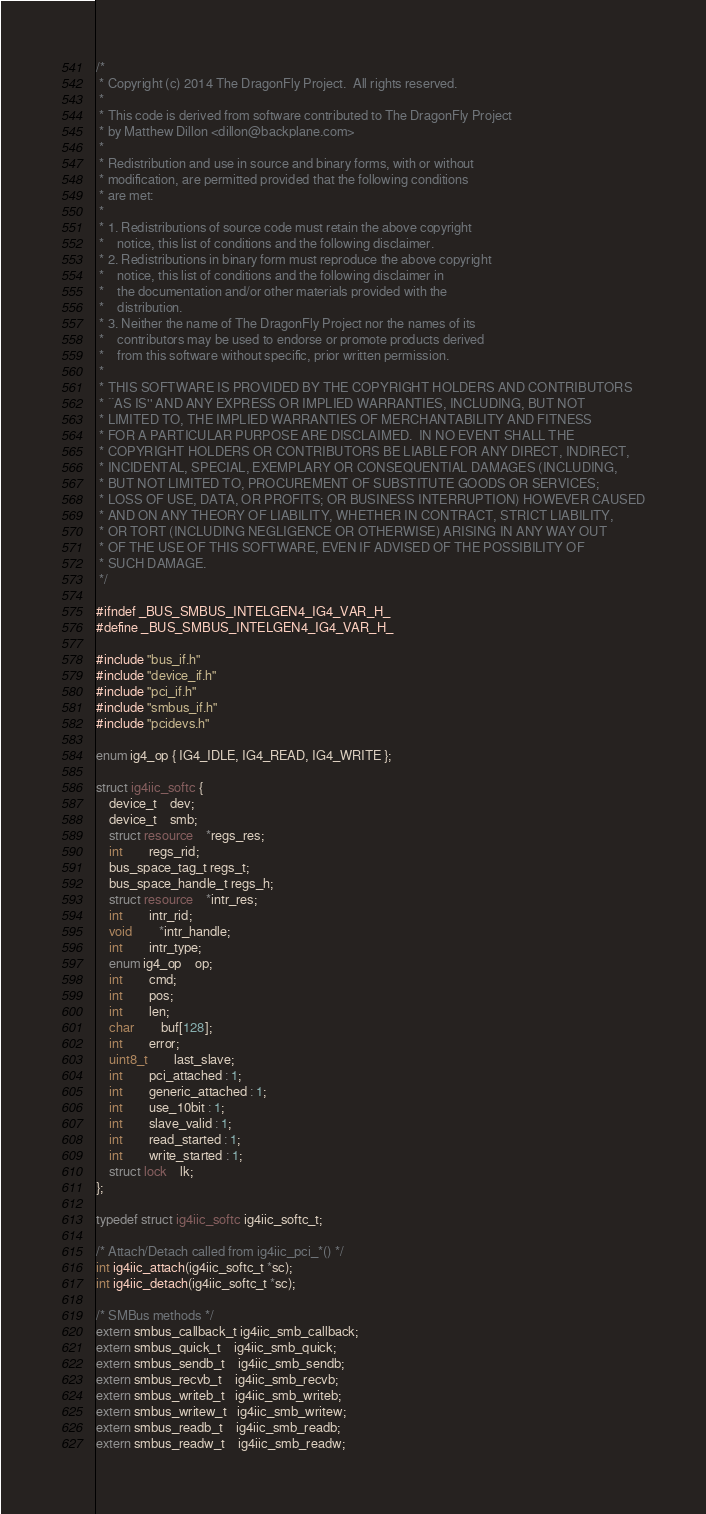<code> <loc_0><loc_0><loc_500><loc_500><_C_>/*
 * Copyright (c) 2014 The DragonFly Project.  All rights reserved.
 *
 * This code is derived from software contributed to The DragonFly Project
 * by Matthew Dillon <dillon@backplane.com>
 *
 * Redistribution and use in source and binary forms, with or without
 * modification, are permitted provided that the following conditions
 * are met:
 *
 * 1. Redistributions of source code must retain the above copyright
 *    notice, this list of conditions and the following disclaimer.
 * 2. Redistributions in binary form must reproduce the above copyright
 *    notice, this list of conditions and the following disclaimer in
 *    the documentation and/or other materials provided with the
 *    distribution.
 * 3. Neither the name of The DragonFly Project nor the names of its
 *    contributors may be used to endorse or promote products derived
 *    from this software without specific, prior written permission.
 *
 * THIS SOFTWARE IS PROVIDED BY THE COPYRIGHT HOLDERS AND CONTRIBUTORS
 * ``AS IS'' AND ANY EXPRESS OR IMPLIED WARRANTIES, INCLUDING, BUT NOT
 * LIMITED TO, THE IMPLIED WARRANTIES OF MERCHANTABILITY AND FITNESS
 * FOR A PARTICULAR PURPOSE ARE DISCLAIMED.  IN NO EVENT SHALL THE
 * COPYRIGHT HOLDERS OR CONTRIBUTORS BE LIABLE FOR ANY DIRECT, INDIRECT,
 * INCIDENTAL, SPECIAL, EXEMPLARY OR CONSEQUENTIAL DAMAGES (INCLUDING,
 * BUT NOT LIMITED TO, PROCUREMENT OF SUBSTITUTE GOODS OR SERVICES;
 * LOSS OF USE, DATA, OR PROFITS; OR BUSINESS INTERRUPTION) HOWEVER CAUSED
 * AND ON ANY THEORY OF LIABILITY, WHETHER IN CONTRACT, STRICT LIABILITY,
 * OR TORT (INCLUDING NEGLIGENCE OR OTHERWISE) ARISING IN ANY WAY OUT
 * OF THE USE OF THIS SOFTWARE, EVEN IF ADVISED OF THE POSSIBILITY OF
 * SUCH DAMAGE.
 */

#ifndef _BUS_SMBUS_INTELGEN4_IG4_VAR_H_
#define _BUS_SMBUS_INTELGEN4_IG4_VAR_H_

#include "bus_if.h"
#include "device_if.h"
#include "pci_if.h"
#include "smbus_if.h"
#include "pcidevs.h"

enum ig4_op { IG4_IDLE, IG4_READ, IG4_WRITE };

struct ig4iic_softc {
	device_t	dev;
	device_t	smb;
	struct resource	*regs_res;
	int		regs_rid;
	bus_space_tag_t regs_t;
	bus_space_handle_t regs_h;
	struct resource	*intr_res;
	int		intr_rid;
	void		*intr_handle;
	int		intr_type;
	enum ig4_op	op;
	int		cmd;
	int		pos;
	int		len;
	char		buf[128];
	int		error;
	uint8_t		last_slave;
	int		pci_attached : 1;
	int		generic_attached : 1;
	int		use_10bit : 1;
	int		slave_valid : 1;
	int		read_started : 1;
	int		write_started : 1;
	struct lock	lk;
};

typedef struct ig4iic_softc ig4iic_softc_t;

/* Attach/Detach called from ig4iic_pci_*() */
int ig4iic_attach(ig4iic_softc_t *sc);
int ig4iic_detach(ig4iic_softc_t *sc);

/* SMBus methods */
extern smbus_callback_t ig4iic_smb_callback;
extern smbus_quick_t    ig4iic_smb_quick;
extern smbus_sendb_t    ig4iic_smb_sendb;
extern smbus_recvb_t    ig4iic_smb_recvb;
extern smbus_writeb_t   ig4iic_smb_writeb;
extern smbus_writew_t   ig4iic_smb_writew;
extern smbus_readb_t    ig4iic_smb_readb;
extern smbus_readw_t    ig4iic_smb_readw;</code> 